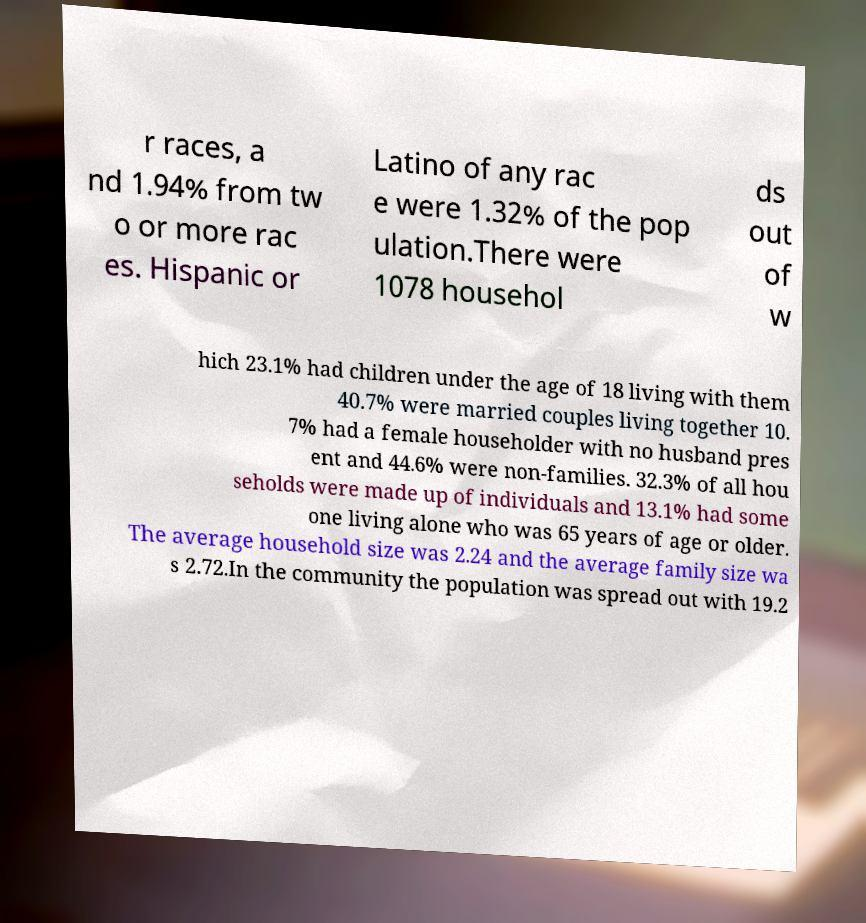Please read and relay the text visible in this image. What does it say? r races, a nd 1.94% from tw o or more rac es. Hispanic or Latino of any rac e were 1.32% of the pop ulation.There were 1078 househol ds out of w hich 23.1% had children under the age of 18 living with them 40.7% were married couples living together 10. 7% had a female householder with no husband pres ent and 44.6% were non-families. 32.3% of all hou seholds were made up of individuals and 13.1% had some one living alone who was 65 years of age or older. The average household size was 2.24 and the average family size wa s 2.72.In the community the population was spread out with 19.2 